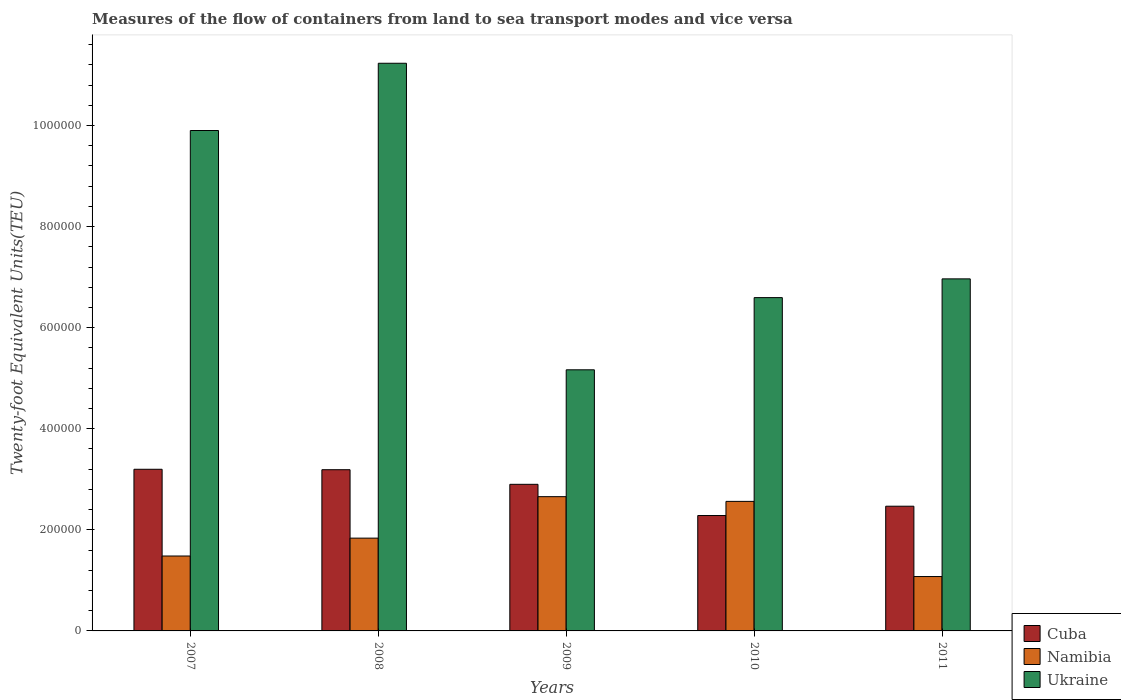How many bars are there on the 2nd tick from the right?
Provide a succinct answer. 3. What is the container port traffic in Ukraine in 2010?
Provide a short and direct response. 6.60e+05. Across all years, what is the maximum container port traffic in Ukraine?
Provide a short and direct response. 1.12e+06. Across all years, what is the minimum container port traffic in Ukraine?
Provide a short and direct response. 5.17e+05. In which year was the container port traffic in Cuba minimum?
Make the answer very short. 2010. What is the total container port traffic in Namibia in the graph?
Offer a very short reply. 9.61e+05. What is the difference between the container port traffic in Ukraine in 2007 and that in 2010?
Your response must be concise. 3.31e+05. What is the difference between the container port traffic in Ukraine in 2010 and the container port traffic in Namibia in 2009?
Your response must be concise. 3.94e+05. What is the average container port traffic in Cuba per year?
Give a very brief answer. 2.81e+05. In the year 2008, what is the difference between the container port traffic in Cuba and container port traffic in Namibia?
Provide a succinct answer. 1.35e+05. In how many years, is the container port traffic in Cuba greater than 480000 TEU?
Offer a very short reply. 0. What is the ratio of the container port traffic in Ukraine in 2009 to that in 2010?
Ensure brevity in your answer.  0.78. What is the difference between the highest and the second highest container port traffic in Ukraine?
Your response must be concise. 1.33e+05. What is the difference between the highest and the lowest container port traffic in Namibia?
Your response must be concise. 1.58e+05. Is the sum of the container port traffic in Ukraine in 2008 and 2010 greater than the maximum container port traffic in Namibia across all years?
Your answer should be very brief. Yes. What does the 2nd bar from the left in 2008 represents?
Give a very brief answer. Namibia. What does the 1st bar from the right in 2008 represents?
Ensure brevity in your answer.  Ukraine. Are all the bars in the graph horizontal?
Provide a short and direct response. No. What is the difference between two consecutive major ticks on the Y-axis?
Your answer should be compact. 2.00e+05. Where does the legend appear in the graph?
Your answer should be very brief. Bottom right. How are the legend labels stacked?
Your answer should be compact. Vertical. What is the title of the graph?
Provide a short and direct response. Measures of the flow of containers from land to sea transport modes and vice versa. What is the label or title of the X-axis?
Offer a terse response. Years. What is the label or title of the Y-axis?
Your answer should be compact. Twenty-foot Equivalent Units(TEU). What is the Twenty-foot Equivalent Units(TEU) of Cuba in 2007?
Ensure brevity in your answer.  3.20e+05. What is the Twenty-foot Equivalent Units(TEU) of Namibia in 2007?
Offer a terse response. 1.48e+05. What is the Twenty-foot Equivalent Units(TEU) in Ukraine in 2007?
Offer a very short reply. 9.90e+05. What is the Twenty-foot Equivalent Units(TEU) of Cuba in 2008?
Ensure brevity in your answer.  3.19e+05. What is the Twenty-foot Equivalent Units(TEU) in Namibia in 2008?
Ensure brevity in your answer.  1.84e+05. What is the Twenty-foot Equivalent Units(TEU) in Ukraine in 2008?
Your answer should be compact. 1.12e+06. What is the Twenty-foot Equivalent Units(TEU) in Cuba in 2009?
Provide a succinct answer. 2.90e+05. What is the Twenty-foot Equivalent Units(TEU) in Namibia in 2009?
Offer a very short reply. 2.66e+05. What is the Twenty-foot Equivalent Units(TEU) in Ukraine in 2009?
Your response must be concise. 5.17e+05. What is the Twenty-foot Equivalent Units(TEU) in Cuba in 2010?
Offer a very short reply. 2.28e+05. What is the Twenty-foot Equivalent Units(TEU) of Namibia in 2010?
Give a very brief answer. 2.56e+05. What is the Twenty-foot Equivalent Units(TEU) in Ukraine in 2010?
Provide a succinct answer. 6.60e+05. What is the Twenty-foot Equivalent Units(TEU) of Cuba in 2011?
Ensure brevity in your answer.  2.47e+05. What is the Twenty-foot Equivalent Units(TEU) of Namibia in 2011?
Your response must be concise. 1.08e+05. What is the Twenty-foot Equivalent Units(TEU) in Ukraine in 2011?
Make the answer very short. 6.97e+05. Across all years, what is the maximum Twenty-foot Equivalent Units(TEU) in Cuba?
Keep it short and to the point. 3.20e+05. Across all years, what is the maximum Twenty-foot Equivalent Units(TEU) in Namibia?
Make the answer very short. 2.66e+05. Across all years, what is the maximum Twenty-foot Equivalent Units(TEU) of Ukraine?
Make the answer very short. 1.12e+06. Across all years, what is the minimum Twenty-foot Equivalent Units(TEU) in Cuba?
Make the answer very short. 2.28e+05. Across all years, what is the minimum Twenty-foot Equivalent Units(TEU) of Namibia?
Make the answer very short. 1.08e+05. Across all years, what is the minimum Twenty-foot Equivalent Units(TEU) of Ukraine?
Your answer should be compact. 5.17e+05. What is the total Twenty-foot Equivalent Units(TEU) in Cuba in the graph?
Provide a short and direct response. 1.40e+06. What is the total Twenty-foot Equivalent Units(TEU) of Namibia in the graph?
Provide a short and direct response. 9.61e+05. What is the total Twenty-foot Equivalent Units(TEU) of Ukraine in the graph?
Your answer should be compact. 3.99e+06. What is the difference between the Twenty-foot Equivalent Units(TEU) in Cuba in 2007 and that in 2008?
Give a very brief answer. 857. What is the difference between the Twenty-foot Equivalent Units(TEU) of Namibia in 2007 and that in 2008?
Provide a short and direct response. -3.54e+04. What is the difference between the Twenty-foot Equivalent Units(TEU) of Ukraine in 2007 and that in 2008?
Make the answer very short. -1.33e+05. What is the difference between the Twenty-foot Equivalent Units(TEU) of Cuba in 2007 and that in 2009?
Provide a succinct answer. 2.98e+04. What is the difference between the Twenty-foot Equivalent Units(TEU) in Namibia in 2007 and that in 2009?
Give a very brief answer. -1.17e+05. What is the difference between the Twenty-foot Equivalent Units(TEU) in Ukraine in 2007 and that in 2009?
Provide a succinct answer. 4.74e+05. What is the difference between the Twenty-foot Equivalent Units(TEU) of Cuba in 2007 and that in 2010?
Your answer should be very brief. 9.15e+04. What is the difference between the Twenty-foot Equivalent Units(TEU) of Namibia in 2007 and that in 2010?
Give a very brief answer. -1.08e+05. What is the difference between the Twenty-foot Equivalent Units(TEU) in Ukraine in 2007 and that in 2010?
Give a very brief answer. 3.31e+05. What is the difference between the Twenty-foot Equivalent Units(TEU) in Cuba in 2007 and that in 2011?
Provide a short and direct response. 7.31e+04. What is the difference between the Twenty-foot Equivalent Units(TEU) of Namibia in 2007 and that in 2011?
Offer a terse response. 4.06e+04. What is the difference between the Twenty-foot Equivalent Units(TEU) of Ukraine in 2007 and that in 2011?
Your response must be concise. 2.94e+05. What is the difference between the Twenty-foot Equivalent Units(TEU) in Cuba in 2008 and that in 2009?
Offer a terse response. 2.89e+04. What is the difference between the Twenty-foot Equivalent Units(TEU) in Namibia in 2008 and that in 2009?
Your answer should be compact. -8.21e+04. What is the difference between the Twenty-foot Equivalent Units(TEU) in Ukraine in 2008 and that in 2009?
Give a very brief answer. 6.07e+05. What is the difference between the Twenty-foot Equivalent Units(TEU) in Cuba in 2008 and that in 2010?
Provide a succinct answer. 9.07e+04. What is the difference between the Twenty-foot Equivalent Units(TEU) in Namibia in 2008 and that in 2010?
Offer a terse response. -7.27e+04. What is the difference between the Twenty-foot Equivalent Units(TEU) of Ukraine in 2008 and that in 2010?
Provide a succinct answer. 4.64e+05. What is the difference between the Twenty-foot Equivalent Units(TEU) in Cuba in 2008 and that in 2011?
Provide a short and direct response. 7.22e+04. What is the difference between the Twenty-foot Equivalent Units(TEU) of Namibia in 2008 and that in 2011?
Provide a short and direct response. 7.60e+04. What is the difference between the Twenty-foot Equivalent Units(TEU) in Ukraine in 2008 and that in 2011?
Your answer should be compact. 4.27e+05. What is the difference between the Twenty-foot Equivalent Units(TEU) of Cuba in 2009 and that in 2010?
Provide a short and direct response. 6.18e+04. What is the difference between the Twenty-foot Equivalent Units(TEU) in Namibia in 2009 and that in 2010?
Your response must be concise. 9344. What is the difference between the Twenty-foot Equivalent Units(TEU) in Ukraine in 2009 and that in 2010?
Offer a terse response. -1.43e+05. What is the difference between the Twenty-foot Equivalent Units(TEU) of Cuba in 2009 and that in 2011?
Ensure brevity in your answer.  4.33e+04. What is the difference between the Twenty-foot Equivalent Units(TEU) of Namibia in 2009 and that in 2011?
Your answer should be very brief. 1.58e+05. What is the difference between the Twenty-foot Equivalent Units(TEU) in Ukraine in 2009 and that in 2011?
Offer a very short reply. -1.80e+05. What is the difference between the Twenty-foot Equivalent Units(TEU) in Cuba in 2010 and that in 2011?
Your answer should be very brief. -1.84e+04. What is the difference between the Twenty-foot Equivalent Units(TEU) in Namibia in 2010 and that in 2011?
Ensure brevity in your answer.  1.49e+05. What is the difference between the Twenty-foot Equivalent Units(TEU) in Ukraine in 2010 and that in 2011?
Ensure brevity in your answer.  -3.71e+04. What is the difference between the Twenty-foot Equivalent Units(TEU) of Cuba in 2007 and the Twenty-foot Equivalent Units(TEU) of Namibia in 2008?
Give a very brief answer. 1.36e+05. What is the difference between the Twenty-foot Equivalent Units(TEU) of Cuba in 2007 and the Twenty-foot Equivalent Units(TEU) of Ukraine in 2008?
Provide a short and direct response. -8.03e+05. What is the difference between the Twenty-foot Equivalent Units(TEU) in Namibia in 2007 and the Twenty-foot Equivalent Units(TEU) in Ukraine in 2008?
Ensure brevity in your answer.  -9.75e+05. What is the difference between the Twenty-foot Equivalent Units(TEU) in Cuba in 2007 and the Twenty-foot Equivalent Units(TEU) in Namibia in 2009?
Provide a short and direct response. 5.42e+04. What is the difference between the Twenty-foot Equivalent Units(TEU) of Cuba in 2007 and the Twenty-foot Equivalent Units(TEU) of Ukraine in 2009?
Give a very brief answer. -1.97e+05. What is the difference between the Twenty-foot Equivalent Units(TEU) in Namibia in 2007 and the Twenty-foot Equivalent Units(TEU) in Ukraine in 2009?
Provide a short and direct response. -3.68e+05. What is the difference between the Twenty-foot Equivalent Units(TEU) of Cuba in 2007 and the Twenty-foot Equivalent Units(TEU) of Namibia in 2010?
Offer a very short reply. 6.35e+04. What is the difference between the Twenty-foot Equivalent Units(TEU) in Cuba in 2007 and the Twenty-foot Equivalent Units(TEU) in Ukraine in 2010?
Ensure brevity in your answer.  -3.40e+05. What is the difference between the Twenty-foot Equivalent Units(TEU) in Namibia in 2007 and the Twenty-foot Equivalent Units(TEU) in Ukraine in 2010?
Offer a terse response. -5.11e+05. What is the difference between the Twenty-foot Equivalent Units(TEU) in Cuba in 2007 and the Twenty-foot Equivalent Units(TEU) in Namibia in 2011?
Your answer should be very brief. 2.12e+05. What is the difference between the Twenty-foot Equivalent Units(TEU) in Cuba in 2007 and the Twenty-foot Equivalent Units(TEU) in Ukraine in 2011?
Ensure brevity in your answer.  -3.77e+05. What is the difference between the Twenty-foot Equivalent Units(TEU) of Namibia in 2007 and the Twenty-foot Equivalent Units(TEU) of Ukraine in 2011?
Provide a succinct answer. -5.48e+05. What is the difference between the Twenty-foot Equivalent Units(TEU) of Cuba in 2008 and the Twenty-foot Equivalent Units(TEU) of Namibia in 2009?
Offer a terse response. 5.33e+04. What is the difference between the Twenty-foot Equivalent Units(TEU) of Cuba in 2008 and the Twenty-foot Equivalent Units(TEU) of Ukraine in 2009?
Your response must be concise. -1.98e+05. What is the difference between the Twenty-foot Equivalent Units(TEU) of Namibia in 2008 and the Twenty-foot Equivalent Units(TEU) of Ukraine in 2009?
Ensure brevity in your answer.  -3.33e+05. What is the difference between the Twenty-foot Equivalent Units(TEU) of Cuba in 2008 and the Twenty-foot Equivalent Units(TEU) of Namibia in 2010?
Offer a terse response. 6.27e+04. What is the difference between the Twenty-foot Equivalent Units(TEU) of Cuba in 2008 and the Twenty-foot Equivalent Units(TEU) of Ukraine in 2010?
Offer a very short reply. -3.41e+05. What is the difference between the Twenty-foot Equivalent Units(TEU) of Namibia in 2008 and the Twenty-foot Equivalent Units(TEU) of Ukraine in 2010?
Your answer should be very brief. -4.76e+05. What is the difference between the Twenty-foot Equivalent Units(TEU) of Cuba in 2008 and the Twenty-foot Equivalent Units(TEU) of Namibia in 2011?
Provide a succinct answer. 2.11e+05. What is the difference between the Twenty-foot Equivalent Units(TEU) in Cuba in 2008 and the Twenty-foot Equivalent Units(TEU) in Ukraine in 2011?
Your answer should be very brief. -3.78e+05. What is the difference between the Twenty-foot Equivalent Units(TEU) of Namibia in 2008 and the Twenty-foot Equivalent Units(TEU) of Ukraine in 2011?
Keep it short and to the point. -5.13e+05. What is the difference between the Twenty-foot Equivalent Units(TEU) of Cuba in 2009 and the Twenty-foot Equivalent Units(TEU) of Namibia in 2010?
Your response must be concise. 3.38e+04. What is the difference between the Twenty-foot Equivalent Units(TEU) in Cuba in 2009 and the Twenty-foot Equivalent Units(TEU) in Ukraine in 2010?
Provide a succinct answer. -3.69e+05. What is the difference between the Twenty-foot Equivalent Units(TEU) of Namibia in 2009 and the Twenty-foot Equivalent Units(TEU) of Ukraine in 2010?
Keep it short and to the point. -3.94e+05. What is the difference between the Twenty-foot Equivalent Units(TEU) of Cuba in 2009 and the Twenty-foot Equivalent Units(TEU) of Namibia in 2011?
Your answer should be compact. 1.82e+05. What is the difference between the Twenty-foot Equivalent Units(TEU) in Cuba in 2009 and the Twenty-foot Equivalent Units(TEU) in Ukraine in 2011?
Ensure brevity in your answer.  -4.07e+05. What is the difference between the Twenty-foot Equivalent Units(TEU) of Namibia in 2009 and the Twenty-foot Equivalent Units(TEU) of Ukraine in 2011?
Ensure brevity in your answer.  -4.31e+05. What is the difference between the Twenty-foot Equivalent Units(TEU) in Cuba in 2010 and the Twenty-foot Equivalent Units(TEU) in Namibia in 2011?
Keep it short and to the point. 1.21e+05. What is the difference between the Twenty-foot Equivalent Units(TEU) in Cuba in 2010 and the Twenty-foot Equivalent Units(TEU) in Ukraine in 2011?
Make the answer very short. -4.68e+05. What is the difference between the Twenty-foot Equivalent Units(TEU) of Namibia in 2010 and the Twenty-foot Equivalent Units(TEU) of Ukraine in 2011?
Keep it short and to the point. -4.40e+05. What is the average Twenty-foot Equivalent Units(TEU) in Cuba per year?
Offer a terse response. 2.81e+05. What is the average Twenty-foot Equivalent Units(TEU) of Namibia per year?
Make the answer very short. 1.92e+05. What is the average Twenty-foot Equivalent Units(TEU) in Ukraine per year?
Keep it short and to the point. 7.97e+05. In the year 2007, what is the difference between the Twenty-foot Equivalent Units(TEU) in Cuba and Twenty-foot Equivalent Units(TEU) in Namibia?
Your answer should be very brief. 1.72e+05. In the year 2007, what is the difference between the Twenty-foot Equivalent Units(TEU) of Cuba and Twenty-foot Equivalent Units(TEU) of Ukraine?
Provide a succinct answer. -6.70e+05. In the year 2007, what is the difference between the Twenty-foot Equivalent Units(TEU) of Namibia and Twenty-foot Equivalent Units(TEU) of Ukraine?
Make the answer very short. -8.42e+05. In the year 2008, what is the difference between the Twenty-foot Equivalent Units(TEU) of Cuba and Twenty-foot Equivalent Units(TEU) of Namibia?
Make the answer very short. 1.35e+05. In the year 2008, what is the difference between the Twenty-foot Equivalent Units(TEU) of Cuba and Twenty-foot Equivalent Units(TEU) of Ukraine?
Provide a succinct answer. -8.04e+05. In the year 2008, what is the difference between the Twenty-foot Equivalent Units(TEU) of Namibia and Twenty-foot Equivalent Units(TEU) of Ukraine?
Give a very brief answer. -9.40e+05. In the year 2009, what is the difference between the Twenty-foot Equivalent Units(TEU) in Cuba and Twenty-foot Equivalent Units(TEU) in Namibia?
Provide a short and direct response. 2.44e+04. In the year 2009, what is the difference between the Twenty-foot Equivalent Units(TEU) in Cuba and Twenty-foot Equivalent Units(TEU) in Ukraine?
Your answer should be very brief. -2.27e+05. In the year 2009, what is the difference between the Twenty-foot Equivalent Units(TEU) of Namibia and Twenty-foot Equivalent Units(TEU) of Ukraine?
Provide a short and direct response. -2.51e+05. In the year 2010, what is the difference between the Twenty-foot Equivalent Units(TEU) in Cuba and Twenty-foot Equivalent Units(TEU) in Namibia?
Your answer should be compact. -2.80e+04. In the year 2010, what is the difference between the Twenty-foot Equivalent Units(TEU) in Cuba and Twenty-foot Equivalent Units(TEU) in Ukraine?
Provide a succinct answer. -4.31e+05. In the year 2010, what is the difference between the Twenty-foot Equivalent Units(TEU) in Namibia and Twenty-foot Equivalent Units(TEU) in Ukraine?
Make the answer very short. -4.03e+05. In the year 2011, what is the difference between the Twenty-foot Equivalent Units(TEU) of Cuba and Twenty-foot Equivalent Units(TEU) of Namibia?
Ensure brevity in your answer.  1.39e+05. In the year 2011, what is the difference between the Twenty-foot Equivalent Units(TEU) in Cuba and Twenty-foot Equivalent Units(TEU) in Ukraine?
Offer a very short reply. -4.50e+05. In the year 2011, what is the difference between the Twenty-foot Equivalent Units(TEU) of Namibia and Twenty-foot Equivalent Units(TEU) of Ukraine?
Give a very brief answer. -5.89e+05. What is the ratio of the Twenty-foot Equivalent Units(TEU) in Cuba in 2007 to that in 2008?
Your answer should be compact. 1. What is the ratio of the Twenty-foot Equivalent Units(TEU) of Namibia in 2007 to that in 2008?
Provide a succinct answer. 0.81. What is the ratio of the Twenty-foot Equivalent Units(TEU) in Ukraine in 2007 to that in 2008?
Your answer should be very brief. 0.88. What is the ratio of the Twenty-foot Equivalent Units(TEU) of Cuba in 2007 to that in 2009?
Provide a succinct answer. 1.1. What is the ratio of the Twenty-foot Equivalent Units(TEU) in Namibia in 2007 to that in 2009?
Keep it short and to the point. 0.56. What is the ratio of the Twenty-foot Equivalent Units(TEU) in Ukraine in 2007 to that in 2009?
Offer a terse response. 1.92. What is the ratio of the Twenty-foot Equivalent Units(TEU) in Cuba in 2007 to that in 2010?
Offer a very short reply. 1.4. What is the ratio of the Twenty-foot Equivalent Units(TEU) in Namibia in 2007 to that in 2010?
Ensure brevity in your answer.  0.58. What is the ratio of the Twenty-foot Equivalent Units(TEU) of Ukraine in 2007 to that in 2010?
Give a very brief answer. 1.5. What is the ratio of the Twenty-foot Equivalent Units(TEU) in Cuba in 2007 to that in 2011?
Offer a very short reply. 1.3. What is the ratio of the Twenty-foot Equivalent Units(TEU) in Namibia in 2007 to that in 2011?
Give a very brief answer. 1.38. What is the ratio of the Twenty-foot Equivalent Units(TEU) in Ukraine in 2007 to that in 2011?
Make the answer very short. 1.42. What is the ratio of the Twenty-foot Equivalent Units(TEU) of Cuba in 2008 to that in 2009?
Give a very brief answer. 1.1. What is the ratio of the Twenty-foot Equivalent Units(TEU) in Namibia in 2008 to that in 2009?
Your answer should be compact. 0.69. What is the ratio of the Twenty-foot Equivalent Units(TEU) in Ukraine in 2008 to that in 2009?
Keep it short and to the point. 2.17. What is the ratio of the Twenty-foot Equivalent Units(TEU) in Cuba in 2008 to that in 2010?
Give a very brief answer. 1.4. What is the ratio of the Twenty-foot Equivalent Units(TEU) of Namibia in 2008 to that in 2010?
Your response must be concise. 0.72. What is the ratio of the Twenty-foot Equivalent Units(TEU) of Ukraine in 2008 to that in 2010?
Keep it short and to the point. 1.7. What is the ratio of the Twenty-foot Equivalent Units(TEU) in Cuba in 2008 to that in 2011?
Offer a very short reply. 1.29. What is the ratio of the Twenty-foot Equivalent Units(TEU) in Namibia in 2008 to that in 2011?
Your answer should be compact. 1.71. What is the ratio of the Twenty-foot Equivalent Units(TEU) of Ukraine in 2008 to that in 2011?
Give a very brief answer. 1.61. What is the ratio of the Twenty-foot Equivalent Units(TEU) in Cuba in 2009 to that in 2010?
Make the answer very short. 1.27. What is the ratio of the Twenty-foot Equivalent Units(TEU) in Namibia in 2009 to that in 2010?
Provide a short and direct response. 1.04. What is the ratio of the Twenty-foot Equivalent Units(TEU) of Ukraine in 2009 to that in 2010?
Keep it short and to the point. 0.78. What is the ratio of the Twenty-foot Equivalent Units(TEU) in Cuba in 2009 to that in 2011?
Keep it short and to the point. 1.18. What is the ratio of the Twenty-foot Equivalent Units(TEU) in Namibia in 2009 to that in 2011?
Your response must be concise. 2.47. What is the ratio of the Twenty-foot Equivalent Units(TEU) in Ukraine in 2009 to that in 2011?
Provide a short and direct response. 0.74. What is the ratio of the Twenty-foot Equivalent Units(TEU) of Cuba in 2010 to that in 2011?
Keep it short and to the point. 0.93. What is the ratio of the Twenty-foot Equivalent Units(TEU) of Namibia in 2010 to that in 2011?
Provide a short and direct response. 2.38. What is the ratio of the Twenty-foot Equivalent Units(TEU) of Ukraine in 2010 to that in 2011?
Your response must be concise. 0.95. What is the difference between the highest and the second highest Twenty-foot Equivalent Units(TEU) in Cuba?
Your answer should be very brief. 857. What is the difference between the highest and the second highest Twenty-foot Equivalent Units(TEU) in Namibia?
Provide a short and direct response. 9344. What is the difference between the highest and the second highest Twenty-foot Equivalent Units(TEU) in Ukraine?
Your answer should be compact. 1.33e+05. What is the difference between the highest and the lowest Twenty-foot Equivalent Units(TEU) of Cuba?
Make the answer very short. 9.15e+04. What is the difference between the highest and the lowest Twenty-foot Equivalent Units(TEU) in Namibia?
Your response must be concise. 1.58e+05. What is the difference between the highest and the lowest Twenty-foot Equivalent Units(TEU) of Ukraine?
Provide a succinct answer. 6.07e+05. 